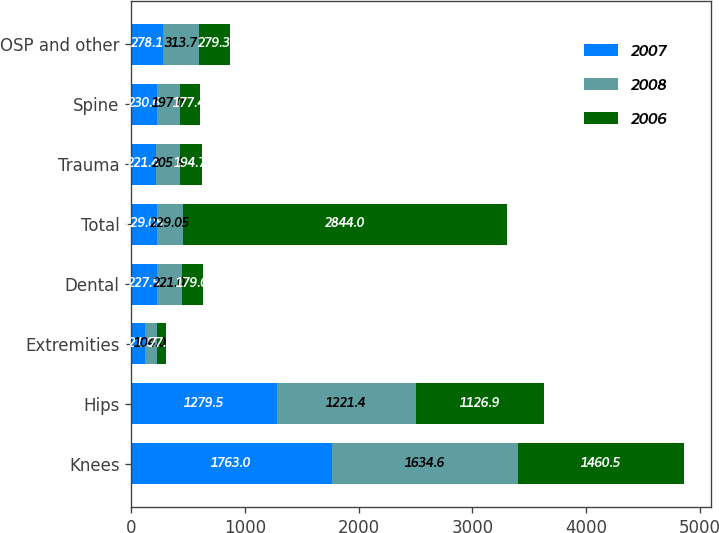<chart> <loc_0><loc_0><loc_500><loc_500><stacked_bar_chart><ecel><fcel>Knees<fcel>Hips<fcel>Extremities<fcel>Dental<fcel>Total<fcel>Trauma<fcel>Spine<fcel>OSP and other<nl><fcel>2007<fcel>1763<fcel>1279.5<fcel>121<fcel>227.5<fcel>229.05<fcel>221.4<fcel>230.6<fcel>278.1<nl><fcel>2008<fcel>1634.6<fcel>1221.4<fcel>104<fcel>221<fcel>229.05<fcel>205.8<fcel>197<fcel>313.7<nl><fcel>2006<fcel>1460.5<fcel>1126.9<fcel>77.6<fcel>179<fcel>2844<fcel>194.7<fcel>177.4<fcel>279.3<nl></chart> 